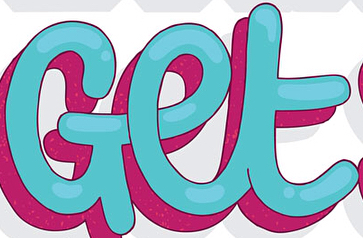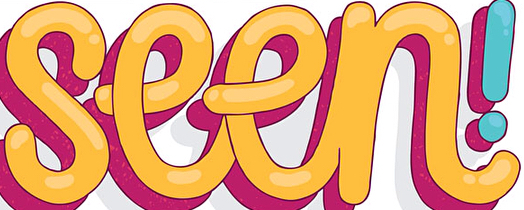What words can you see in these images in sequence, separated by a semicolon? Get; seen 